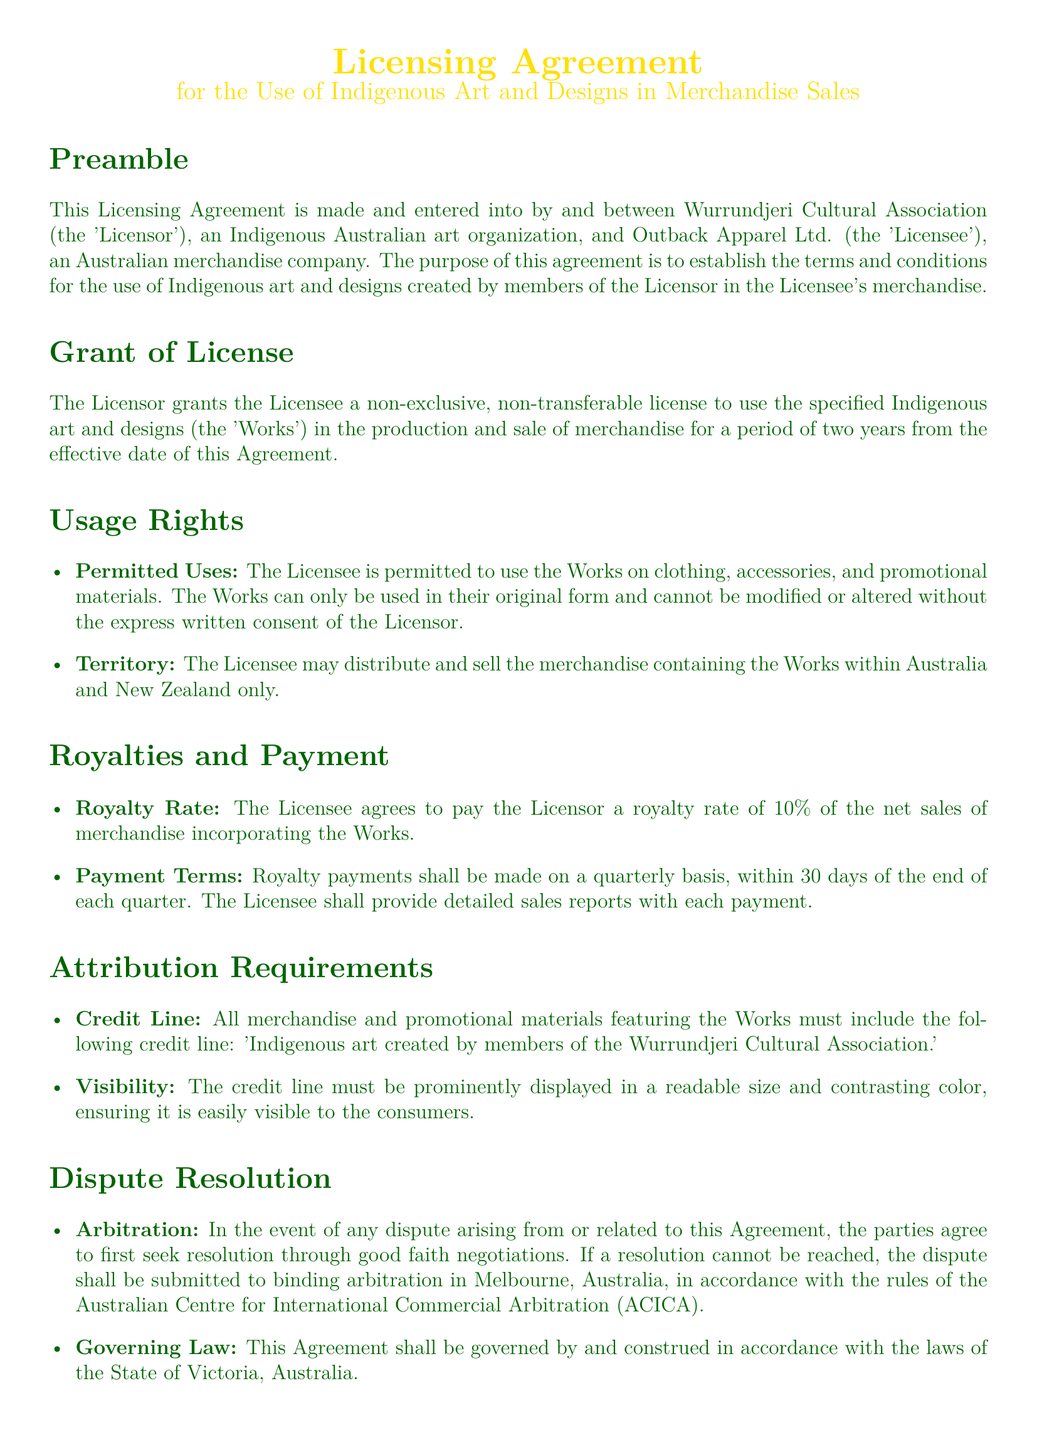What is the effective period of the license? The effective period of the license is specified in the "Grant of License" section of the document, which states it is for a period of two years from the effective date of the Agreement.
Answer: two years What is the royalty rate for the use of the Works? The royalty rate is mentioned in the "Royalties and Payment" section, which indicates the Licensee agrees to pay 10% of the net sales of merchandise incorporating the Works.
Answer: 10% Who is the Licensor in this agreement? The Licensor is identified in the preamble of the document, which states that it is the Wurrundjeri Cultural Association.
Answer: Wurrundjeri Cultural Association What must be included in the credit line for the merchandise? The "Attribution Requirements" section outlines what is necessary in the credit line, which is 'Indigenous art created by members of the Wurrundjeri Cultural Association.'
Answer: Indigenous art created by members of the Wurrundjeri Cultural Association Where shall disputes be submitted for resolution? The "Dispute Resolution" section specifies that disputes shall be submitted to binding arbitration in Melbourne, Australia.
Answer: Melbourne What is the governing law of the Agreement? The "Dispute Resolution" section indicates that the governing law is specified there, according to which this Agreement shall be governed by the laws of the State of Victoria, Australia.
Answer: State of Victoria What must the Licensee provide along with royalty payments? The "Payment Terms" subsection indicates that the Licensee shall provide detailed sales reports with each royalty payment.
Answer: detailed sales reports What are the permitted uses of the Works? The "Usage Rights" section describes the permitted uses, stating that the Works may be used on clothing, accessories, and promotional materials.
Answer: clothing, accessories, and promotional materials Are the Works allowed to be modified? The "Usage Rights" section mentions that the Works cannot be modified or altered without the express written consent of the Licensor.
Answer: no 